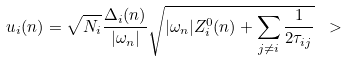<formula> <loc_0><loc_0><loc_500><loc_500>u _ { i } ( n ) = \sqrt { N _ { i } } \frac { \Delta _ { i } ( n ) } { | \omega _ { n } | } \sqrt { | \omega _ { n } | Z _ { i } ^ { 0 } ( n ) + \sum _ { j \neq i } \frac { 1 } { 2 \tau _ { i j } } } \ ></formula> 